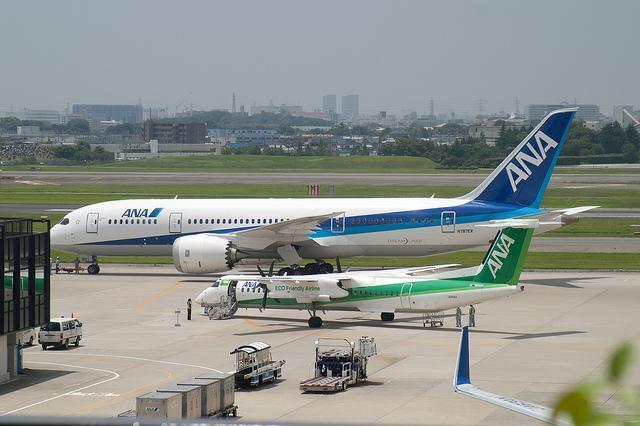Which vehicle can carry the most volume of supplies?
Choose the correct response and explain in the format: 'Answer: answer
Rationale: rationale.'
Options: Green plane, blue plane, van, luggage cart. Answer: blue plane.
Rationale: The vehicle is the blue plane. 